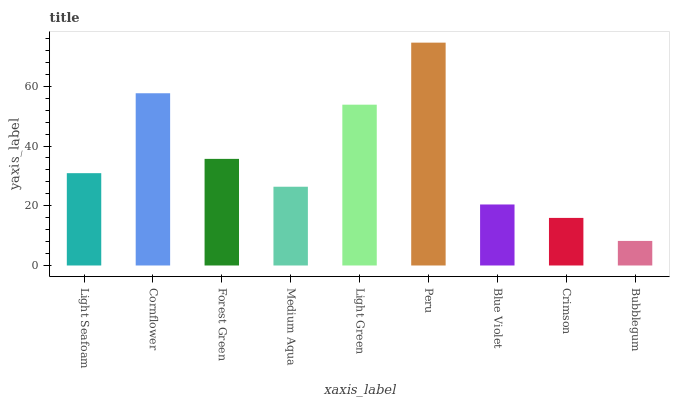Is Bubblegum the minimum?
Answer yes or no. Yes. Is Peru the maximum?
Answer yes or no. Yes. Is Cornflower the minimum?
Answer yes or no. No. Is Cornflower the maximum?
Answer yes or no. No. Is Cornflower greater than Light Seafoam?
Answer yes or no. Yes. Is Light Seafoam less than Cornflower?
Answer yes or no. Yes. Is Light Seafoam greater than Cornflower?
Answer yes or no. No. Is Cornflower less than Light Seafoam?
Answer yes or no. No. Is Light Seafoam the high median?
Answer yes or no. Yes. Is Light Seafoam the low median?
Answer yes or no. Yes. Is Medium Aqua the high median?
Answer yes or no. No. Is Light Green the low median?
Answer yes or no. No. 